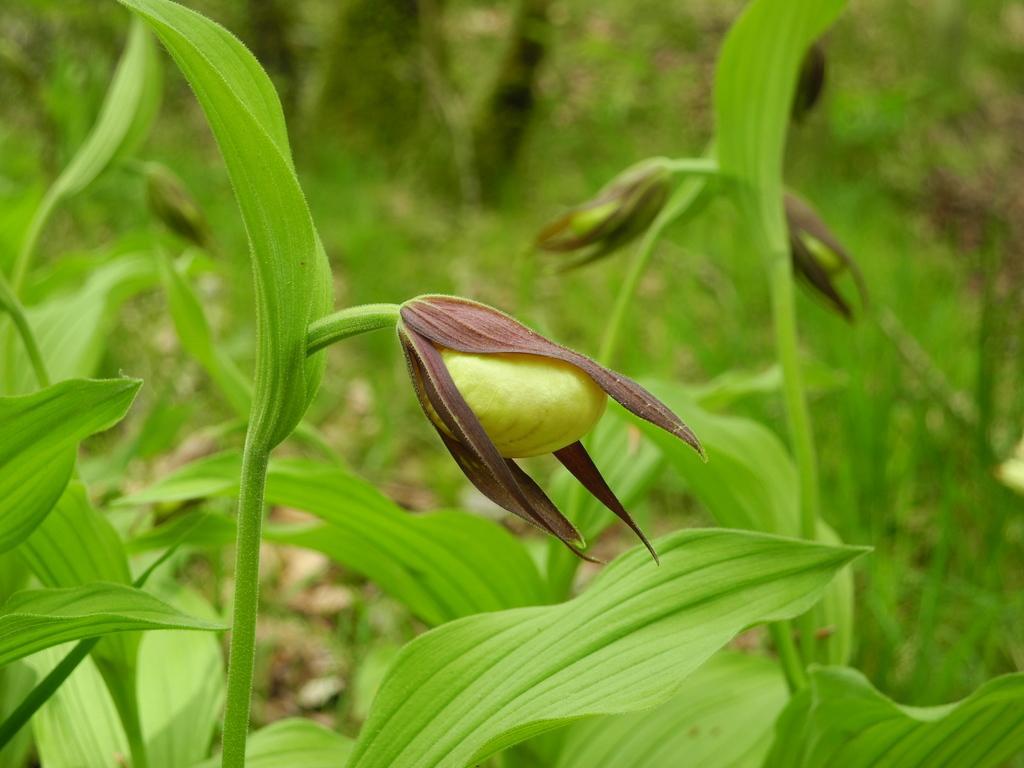Could you give a brief overview of what you see in this image? This picture shows plants and we see buds. 